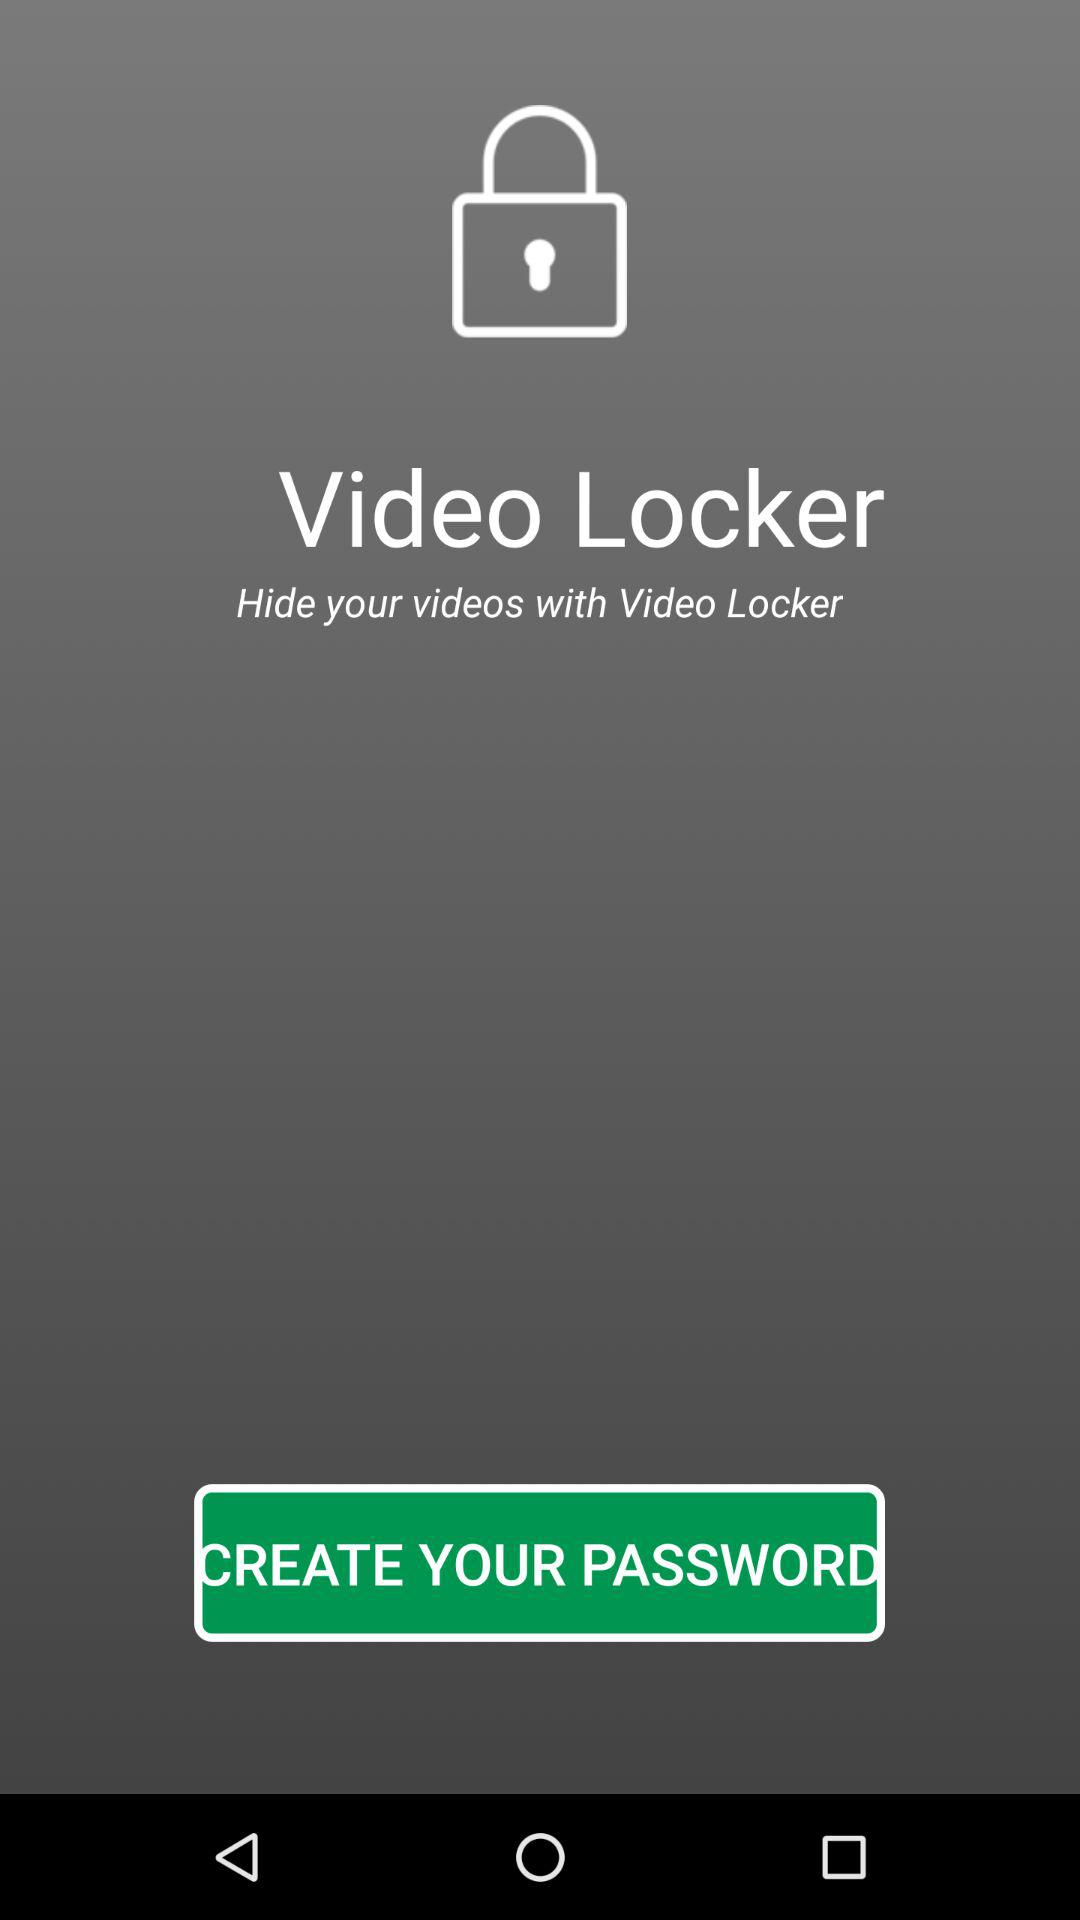What is the name of the application? The name of the application is "Video Locker". 